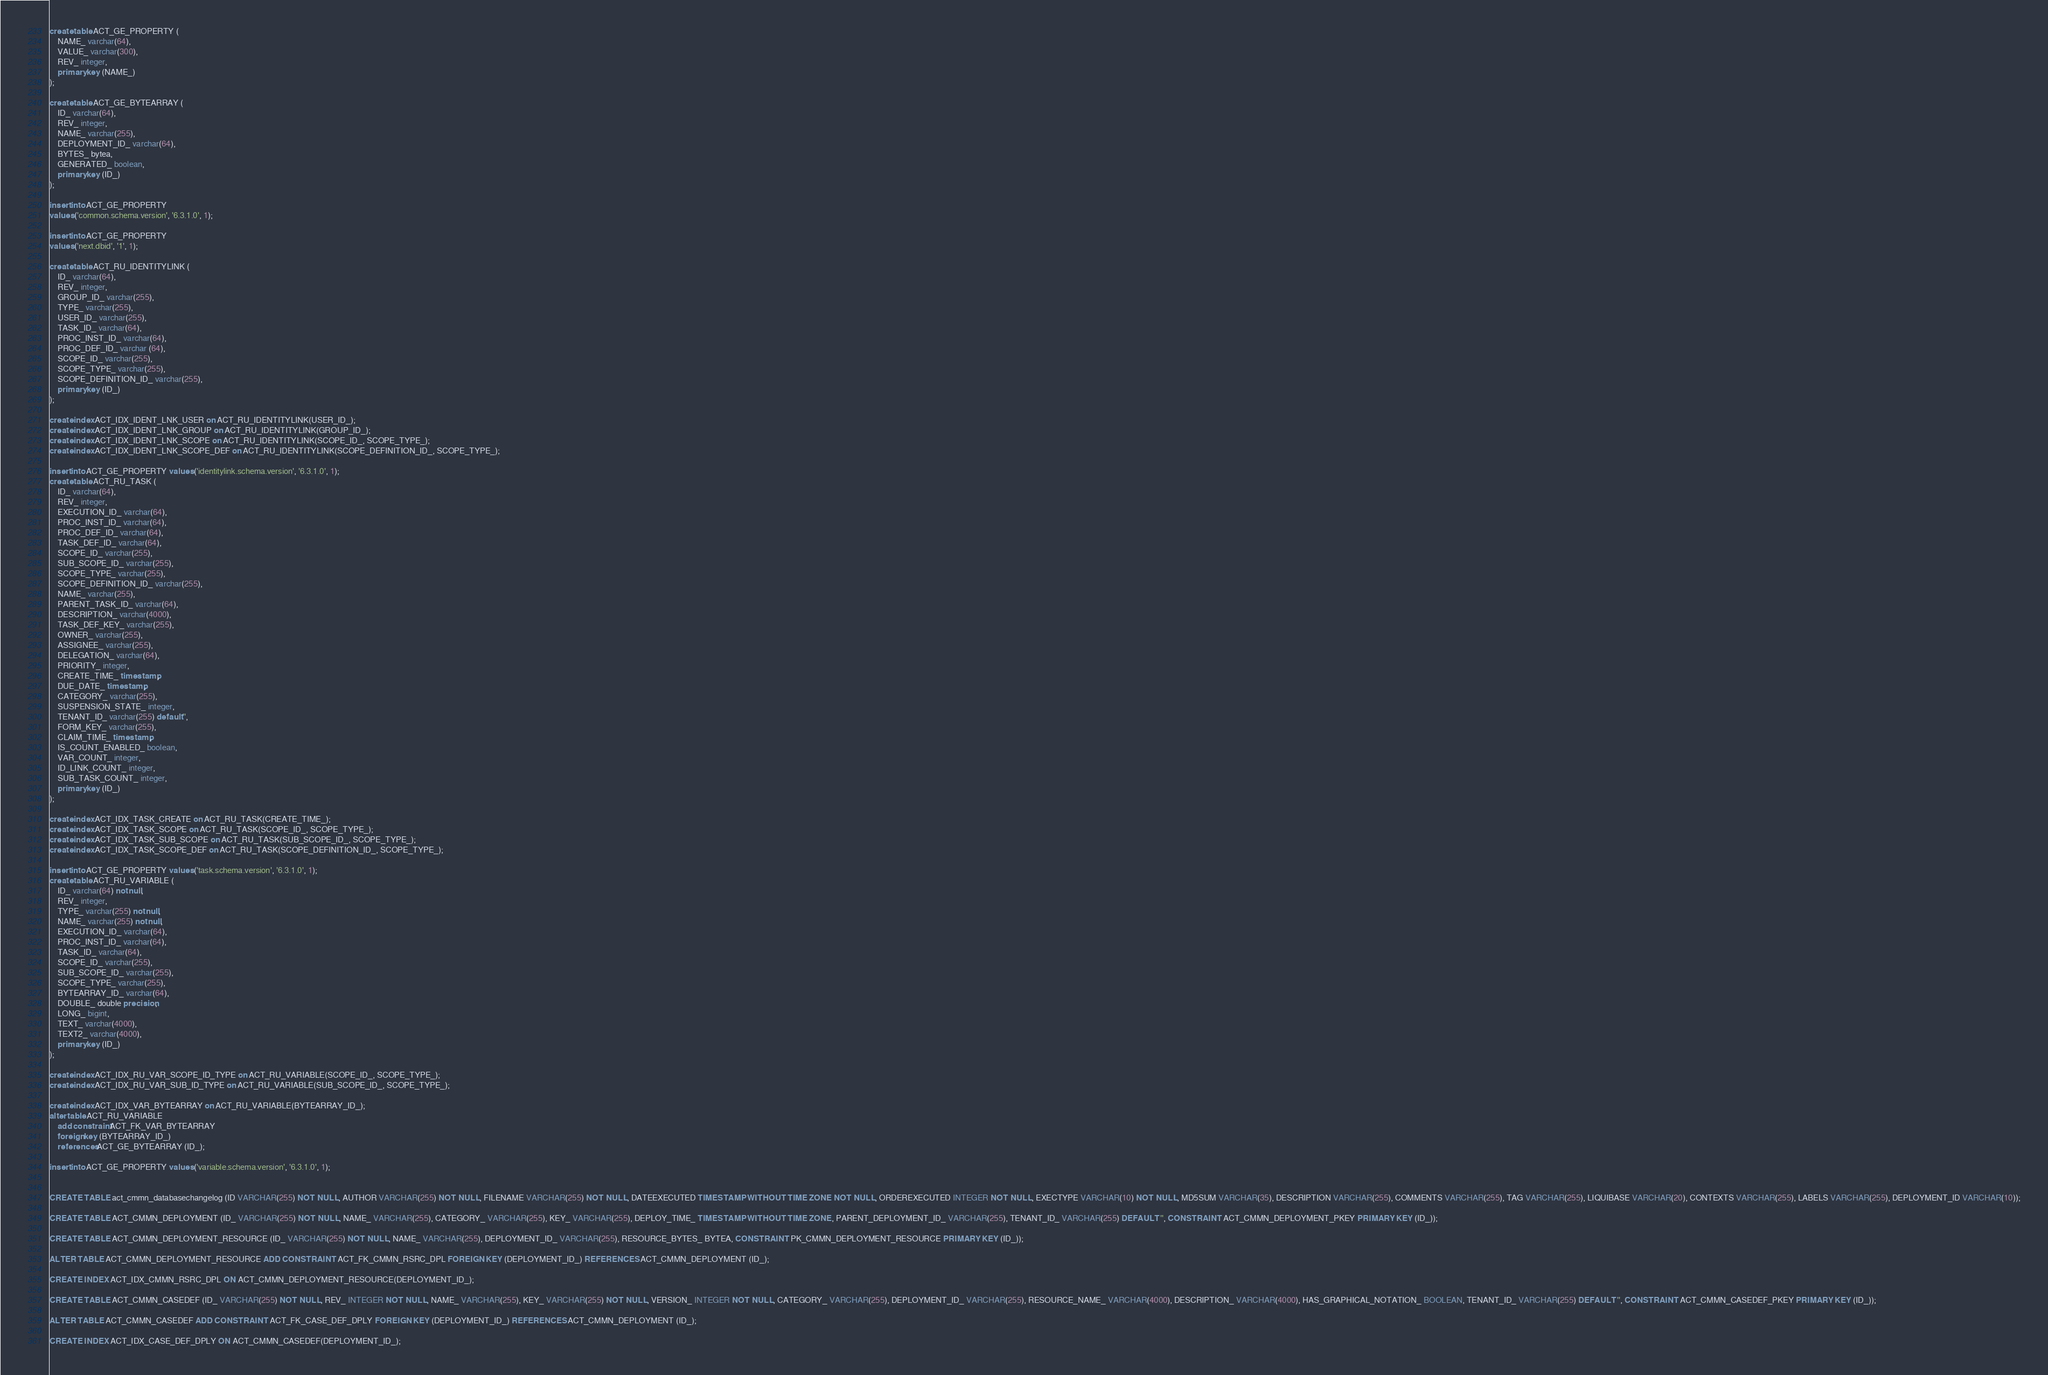<code> <loc_0><loc_0><loc_500><loc_500><_SQL_>create table ACT_GE_PROPERTY (
    NAME_ varchar(64),
    VALUE_ varchar(300),
    REV_ integer,
    primary key (NAME_)
);

create table ACT_GE_BYTEARRAY (
    ID_ varchar(64),
    REV_ integer,
    NAME_ varchar(255),
    DEPLOYMENT_ID_ varchar(64),
    BYTES_ bytea,
    GENERATED_ boolean,
    primary key (ID_)
);

insert into ACT_GE_PROPERTY
values ('common.schema.version', '6.3.1.0', 1);

insert into ACT_GE_PROPERTY
values ('next.dbid', '1', 1);

create table ACT_RU_IDENTITYLINK (
    ID_ varchar(64),
    REV_ integer,
    GROUP_ID_ varchar(255),
    TYPE_ varchar(255),
    USER_ID_ varchar(255),
    TASK_ID_ varchar(64),
    PROC_INST_ID_ varchar(64),
    PROC_DEF_ID_ varchar (64),
    SCOPE_ID_ varchar(255),
    SCOPE_TYPE_ varchar(255),
    SCOPE_DEFINITION_ID_ varchar(255),
    primary key (ID_)
);

create index ACT_IDX_IDENT_LNK_USER on ACT_RU_IDENTITYLINK(USER_ID_);
create index ACT_IDX_IDENT_LNK_GROUP on ACT_RU_IDENTITYLINK(GROUP_ID_);
create index ACT_IDX_IDENT_LNK_SCOPE on ACT_RU_IDENTITYLINK(SCOPE_ID_, SCOPE_TYPE_);
create index ACT_IDX_IDENT_LNK_SCOPE_DEF on ACT_RU_IDENTITYLINK(SCOPE_DEFINITION_ID_, SCOPE_TYPE_);

insert into ACT_GE_PROPERTY values ('identitylink.schema.version', '6.3.1.0', 1);
create table ACT_RU_TASK (
    ID_ varchar(64),
    REV_ integer,
    EXECUTION_ID_ varchar(64),
    PROC_INST_ID_ varchar(64),
    PROC_DEF_ID_ varchar(64),
    TASK_DEF_ID_ varchar(64),
    SCOPE_ID_ varchar(255),
    SUB_SCOPE_ID_ varchar(255),
    SCOPE_TYPE_ varchar(255),
    SCOPE_DEFINITION_ID_ varchar(255),
    NAME_ varchar(255),
    PARENT_TASK_ID_ varchar(64),
    DESCRIPTION_ varchar(4000),
    TASK_DEF_KEY_ varchar(255),
    OWNER_ varchar(255),
    ASSIGNEE_ varchar(255),
    DELEGATION_ varchar(64),
    PRIORITY_ integer,
    CREATE_TIME_ timestamp,
    DUE_DATE_ timestamp,
    CATEGORY_ varchar(255),
    SUSPENSION_STATE_ integer,
    TENANT_ID_ varchar(255) default '',
    FORM_KEY_ varchar(255),
    CLAIM_TIME_ timestamp,
    IS_COUNT_ENABLED_ boolean,
    VAR_COUNT_ integer, 
    ID_LINK_COUNT_ integer,
    SUB_TASK_COUNT_ integer,
    primary key (ID_)
);

create index ACT_IDX_TASK_CREATE on ACT_RU_TASK(CREATE_TIME_);
create index ACT_IDX_TASK_SCOPE on ACT_RU_TASK(SCOPE_ID_, SCOPE_TYPE_);
create index ACT_IDX_TASK_SUB_SCOPE on ACT_RU_TASK(SUB_SCOPE_ID_, SCOPE_TYPE_);
create index ACT_IDX_TASK_SCOPE_DEF on ACT_RU_TASK(SCOPE_DEFINITION_ID_, SCOPE_TYPE_);

insert into ACT_GE_PROPERTY values ('task.schema.version', '6.3.1.0', 1);
create table ACT_RU_VARIABLE (
    ID_ varchar(64) not null,
    REV_ integer,
    TYPE_ varchar(255) not null,
    NAME_ varchar(255) not null,
    EXECUTION_ID_ varchar(64),
    PROC_INST_ID_ varchar(64),
    TASK_ID_ varchar(64),
    SCOPE_ID_ varchar(255),
    SUB_SCOPE_ID_ varchar(255),
    SCOPE_TYPE_ varchar(255),
    BYTEARRAY_ID_ varchar(64),
    DOUBLE_ double precision,
    LONG_ bigint,
    TEXT_ varchar(4000),
    TEXT2_ varchar(4000),
    primary key (ID_)
);

create index ACT_IDX_RU_VAR_SCOPE_ID_TYPE on ACT_RU_VARIABLE(SCOPE_ID_, SCOPE_TYPE_);
create index ACT_IDX_RU_VAR_SUB_ID_TYPE on ACT_RU_VARIABLE(SUB_SCOPE_ID_, SCOPE_TYPE_);

create index ACT_IDX_VAR_BYTEARRAY on ACT_RU_VARIABLE(BYTEARRAY_ID_);
alter table ACT_RU_VARIABLE 
    add constraint ACT_FK_VAR_BYTEARRAY 
    foreign key (BYTEARRAY_ID_) 
    references ACT_GE_BYTEARRAY (ID_);

insert into ACT_GE_PROPERTY values ('variable.schema.version', '6.3.1.0', 1);


CREATE TABLE act_cmmn_databasechangelog (ID VARCHAR(255) NOT NULL, AUTHOR VARCHAR(255) NOT NULL, FILENAME VARCHAR(255) NOT NULL, DATEEXECUTED TIMESTAMP WITHOUT TIME ZONE NOT NULL, ORDEREXECUTED INTEGER NOT NULL, EXECTYPE VARCHAR(10) NOT NULL, MD5SUM VARCHAR(35), DESCRIPTION VARCHAR(255), COMMENTS VARCHAR(255), TAG VARCHAR(255), LIQUIBASE VARCHAR(20), CONTEXTS VARCHAR(255), LABELS VARCHAR(255), DEPLOYMENT_ID VARCHAR(10));

CREATE TABLE ACT_CMMN_DEPLOYMENT (ID_ VARCHAR(255) NOT NULL, NAME_ VARCHAR(255), CATEGORY_ VARCHAR(255), KEY_ VARCHAR(255), DEPLOY_TIME_ TIMESTAMP WITHOUT TIME ZONE, PARENT_DEPLOYMENT_ID_ VARCHAR(255), TENANT_ID_ VARCHAR(255) DEFAULT '', CONSTRAINT ACT_CMMN_DEPLOYMENT_PKEY PRIMARY KEY (ID_));

CREATE TABLE ACT_CMMN_DEPLOYMENT_RESOURCE (ID_ VARCHAR(255) NOT NULL, NAME_ VARCHAR(255), DEPLOYMENT_ID_ VARCHAR(255), RESOURCE_BYTES_ BYTEA, CONSTRAINT PK_CMMN_DEPLOYMENT_RESOURCE PRIMARY KEY (ID_));

ALTER TABLE ACT_CMMN_DEPLOYMENT_RESOURCE ADD CONSTRAINT ACT_FK_CMMN_RSRC_DPL FOREIGN KEY (DEPLOYMENT_ID_) REFERENCES ACT_CMMN_DEPLOYMENT (ID_);

CREATE INDEX ACT_IDX_CMMN_RSRC_DPL ON ACT_CMMN_DEPLOYMENT_RESOURCE(DEPLOYMENT_ID_);

CREATE TABLE ACT_CMMN_CASEDEF (ID_ VARCHAR(255) NOT NULL, REV_ INTEGER NOT NULL, NAME_ VARCHAR(255), KEY_ VARCHAR(255) NOT NULL, VERSION_ INTEGER NOT NULL, CATEGORY_ VARCHAR(255), DEPLOYMENT_ID_ VARCHAR(255), RESOURCE_NAME_ VARCHAR(4000), DESCRIPTION_ VARCHAR(4000), HAS_GRAPHICAL_NOTATION_ BOOLEAN, TENANT_ID_ VARCHAR(255) DEFAULT '', CONSTRAINT ACT_CMMN_CASEDEF_PKEY PRIMARY KEY (ID_));

ALTER TABLE ACT_CMMN_CASEDEF ADD CONSTRAINT ACT_FK_CASE_DEF_DPLY FOREIGN KEY (DEPLOYMENT_ID_) REFERENCES ACT_CMMN_DEPLOYMENT (ID_);

CREATE INDEX ACT_IDX_CASE_DEF_DPLY ON ACT_CMMN_CASEDEF(DEPLOYMENT_ID_);
</code> 